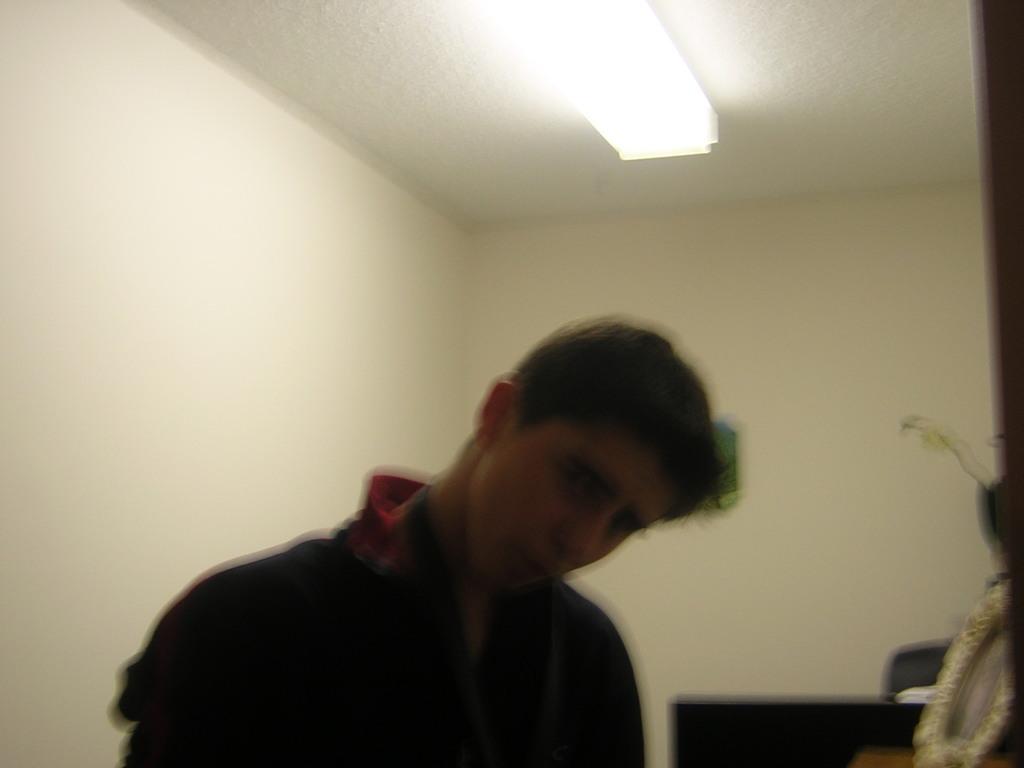Describe this image in one or two sentences. In this image there is one person standing as we can see at bottom of this image and there is a light at top of this image and there are some objects kept at bottom right corner of this image and there is a wall in the background. 